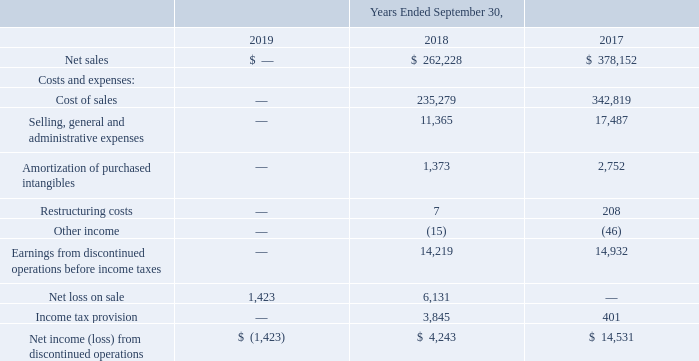NOTE 3—ACQUISITIONS AND DIVESTITURES
Sale of CGD Services
On April 18, 2018, we entered into a stock purchase agreement with Nova Global Supply & Services, LLC (Purchaser), an entity affiliated with GC Valiant, LP, under which we agreed to sell our CGD Services business to the Purchaser. We concluded that the sale of the CGD Services business met all of the required conditions for discontinued operations presentation in the second quarter of fiscal 2018. Consequently, in the second quarter of fiscal 2018, we recognized a $6.9 million loss within discontinued operations, which was calculated as the excess of the carrying value of the net assets of CGD Services less the estimated sales price in the stock purchase agreement less estimated selling costs.
The sale closed on May 31, 2018. In accordance with the terms of the stock purchase agreement, the Purchaser agreed to pay us $135.0 million in cash upon the closing of the transaction, adjusted for the estimated working capital of CGD Services at the date of the sale compared to a working capital target. In the third quarter of fiscal 2018, we received $133.8 million in connection with the sale and we recorded a receivable from the Purchaser for the estimated amount due related to the working capital settlement. The balance of this receivable was $3.7 million at September 30, 2018. During fiscal 2019, we worked with the Purchaser and revised certain estimates related to the working capital settlement. In connection with the revision of these estimates, we reduced the receivable from the Purchaser by $1.4 million and recognized a corresponding loss on the sale of CGD Services in fiscal 2019. Certain remaining working capital settlement estimates, primarily related to the fair value of accounts receivable, have not yet been settled with the Purchaser.
In addition to the amounts described above, we are eligible to receive an additional cash payment of $3.0 million based on the achievement of pre-determined earn-out conditions related to the award of certain government contracts. No amount has been recorded as a receivable related to the potential achievement of earn-out conditions based upon our assessment of the probability of achievement of the required conditions.
The operations and cash flows of CGD Services are reflected in our Consolidated Statements of Operations and Consolidated Statements of Cash Flows as discontinued operations through May 31, 2018, the date of the sale. The following table presents the composition of net income from discontinued operations, net of taxes (in thousands):
How was the loss within discontinued operations in 2018 calculated? The excess of the carrying value of the net assets of cgd services less the estimated sales price in the stock purchase agreement less estimated selling costs. What is the eligibility to receive an additional cash payment of $3.0 million based on? The achievement of pre-determined earn-out conditions related to the award of certain government contracts. What are the components under Costs and Expenses? Cost of sales, selling, general and administrative expenses, amortization of purchased intangibles, restructuring costs, other income. How many components are there under Costs and Expenses? Cost of sales##Selling, general and administrative expenses##Amortization of purchased intangibles##Restructuring costs##Other income
Answer: 5. What is the change in net sales in 2018 from 2017?
Answer scale should be: thousand. 262,228-378,152
Answer: -115924. What is the percentage change in net sales in 2018 from 2017?
Answer scale should be: percent. (262,228-378,152)/378,152
Answer: -30.66. 